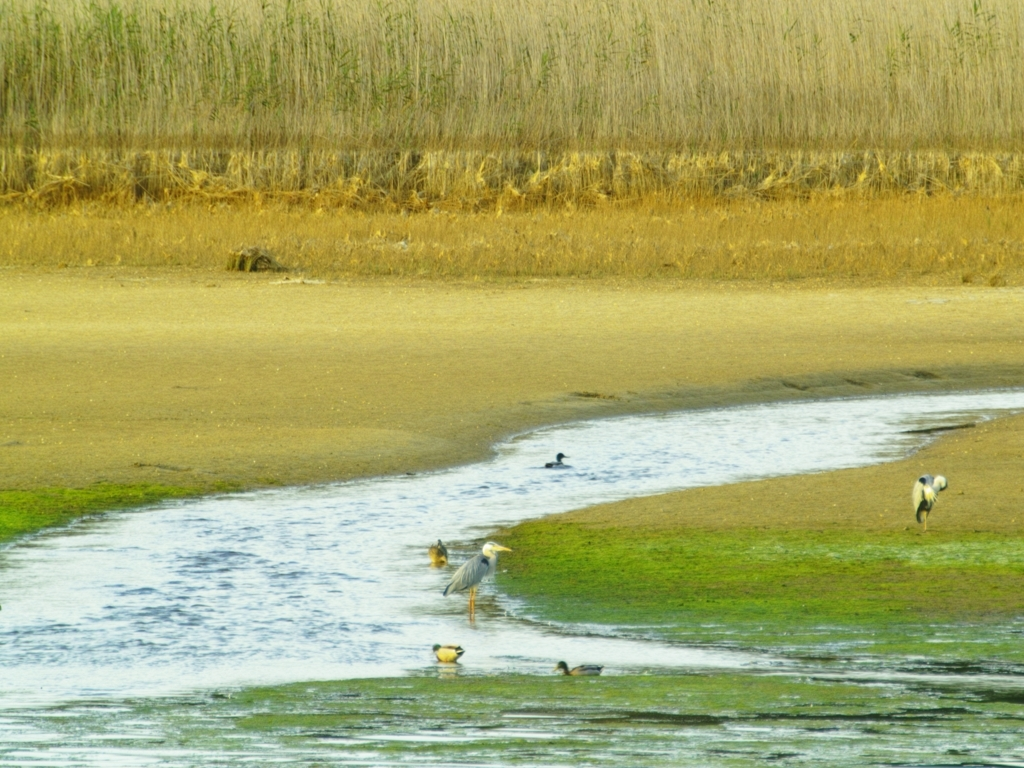Can you tell me what kind of habitat this is? This appears to be a wetland habitat, characterized by the presence of standing water, water-loving vegetation, and a variety of birds that depend on this environment for food and shelter. 